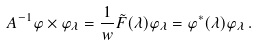<formula> <loc_0><loc_0><loc_500><loc_500>\ A ^ { - 1 } \varphi \times \varphi _ { \lambda } = \frac { 1 } { w } \tilde { F } ( \lambda ) \varphi _ { \lambda } = \varphi ^ { * } ( \lambda ) \varphi _ { \lambda } \, .</formula> 